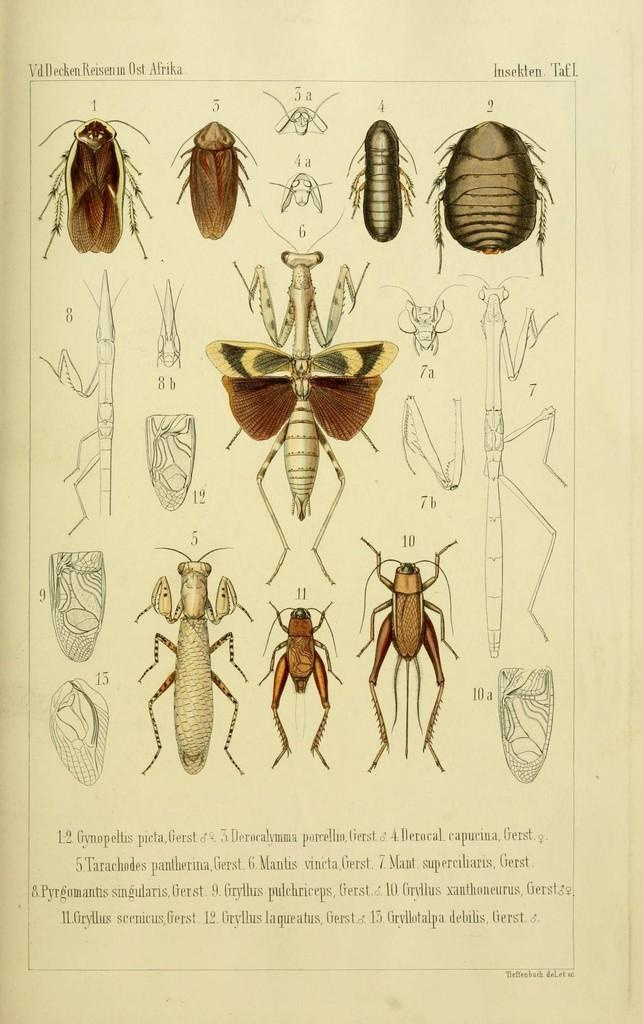What is featured on the poster in the image? The poster in the image has pictures of insects. Is there any text on the poster? Yes, there is text on the poster. Can you describe the insect images on the poster? The poster features insect images. Where is the text located on the poster? The text is at the bottom of the image. What type of pie is being baked on the stove in the image? There is no stove or pie present in the image; it features a poster with insect images and text. 